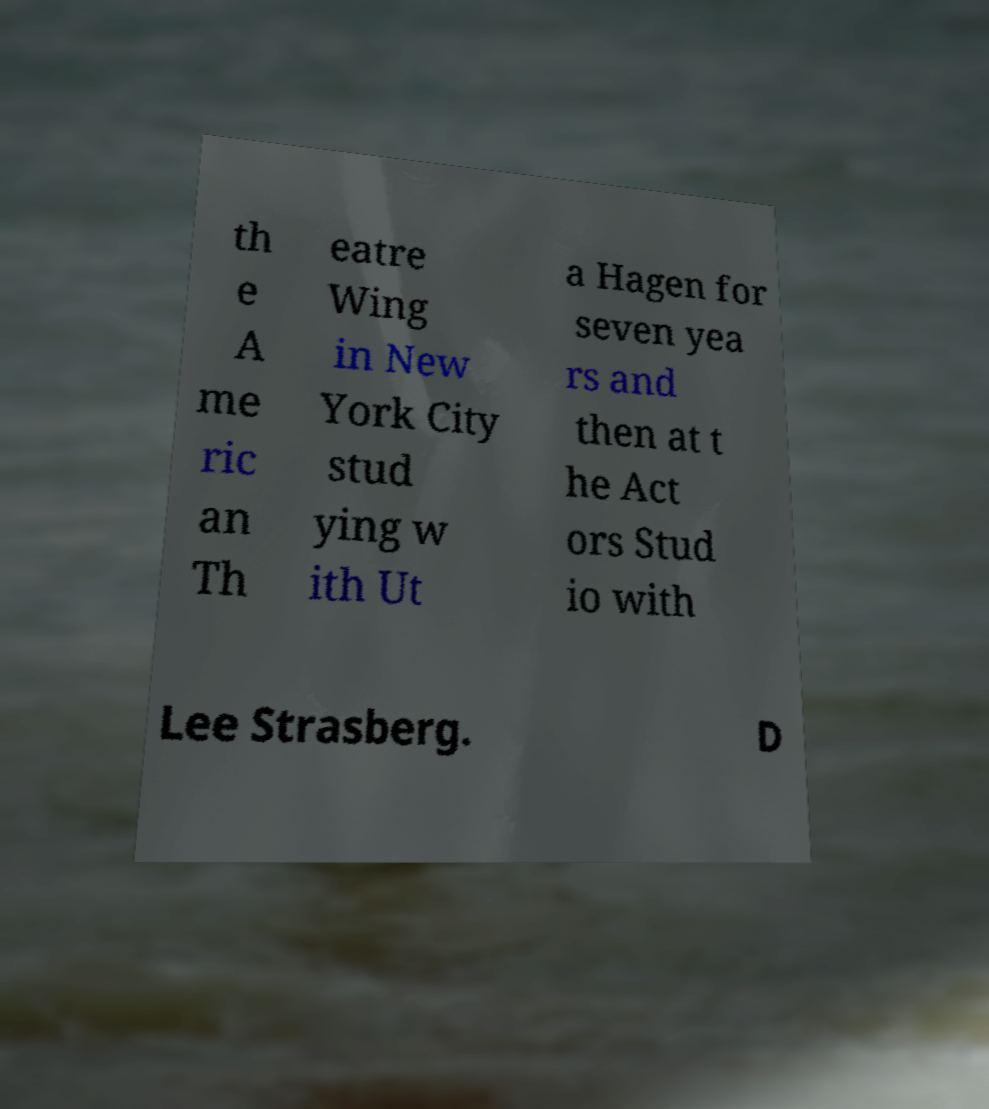For documentation purposes, I need the text within this image transcribed. Could you provide that? th e A me ric an Th eatre Wing in New York City stud ying w ith Ut a Hagen for seven yea rs and then at t he Act ors Stud io with Lee Strasberg. D 